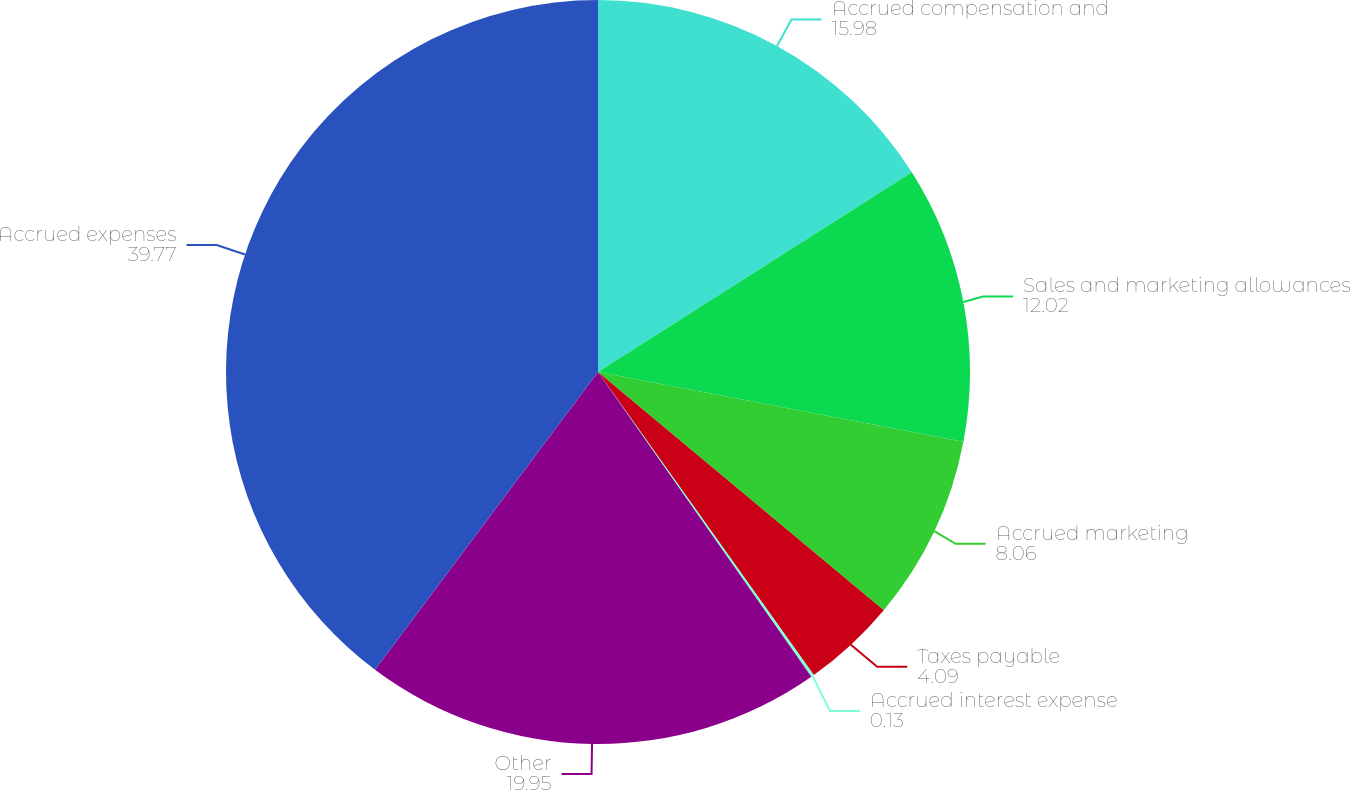Convert chart. <chart><loc_0><loc_0><loc_500><loc_500><pie_chart><fcel>Accrued compensation and<fcel>Sales and marketing allowances<fcel>Accrued marketing<fcel>Taxes payable<fcel>Accrued interest expense<fcel>Other<fcel>Accrued expenses<nl><fcel>15.98%<fcel>12.02%<fcel>8.06%<fcel>4.09%<fcel>0.13%<fcel>19.95%<fcel>39.77%<nl></chart> 